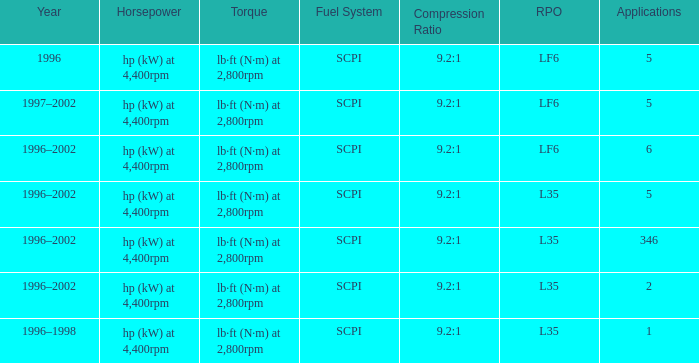What are the torque characteristics of the model with 346 applications? Lb·ft (n·m) at 2,800rpm. 